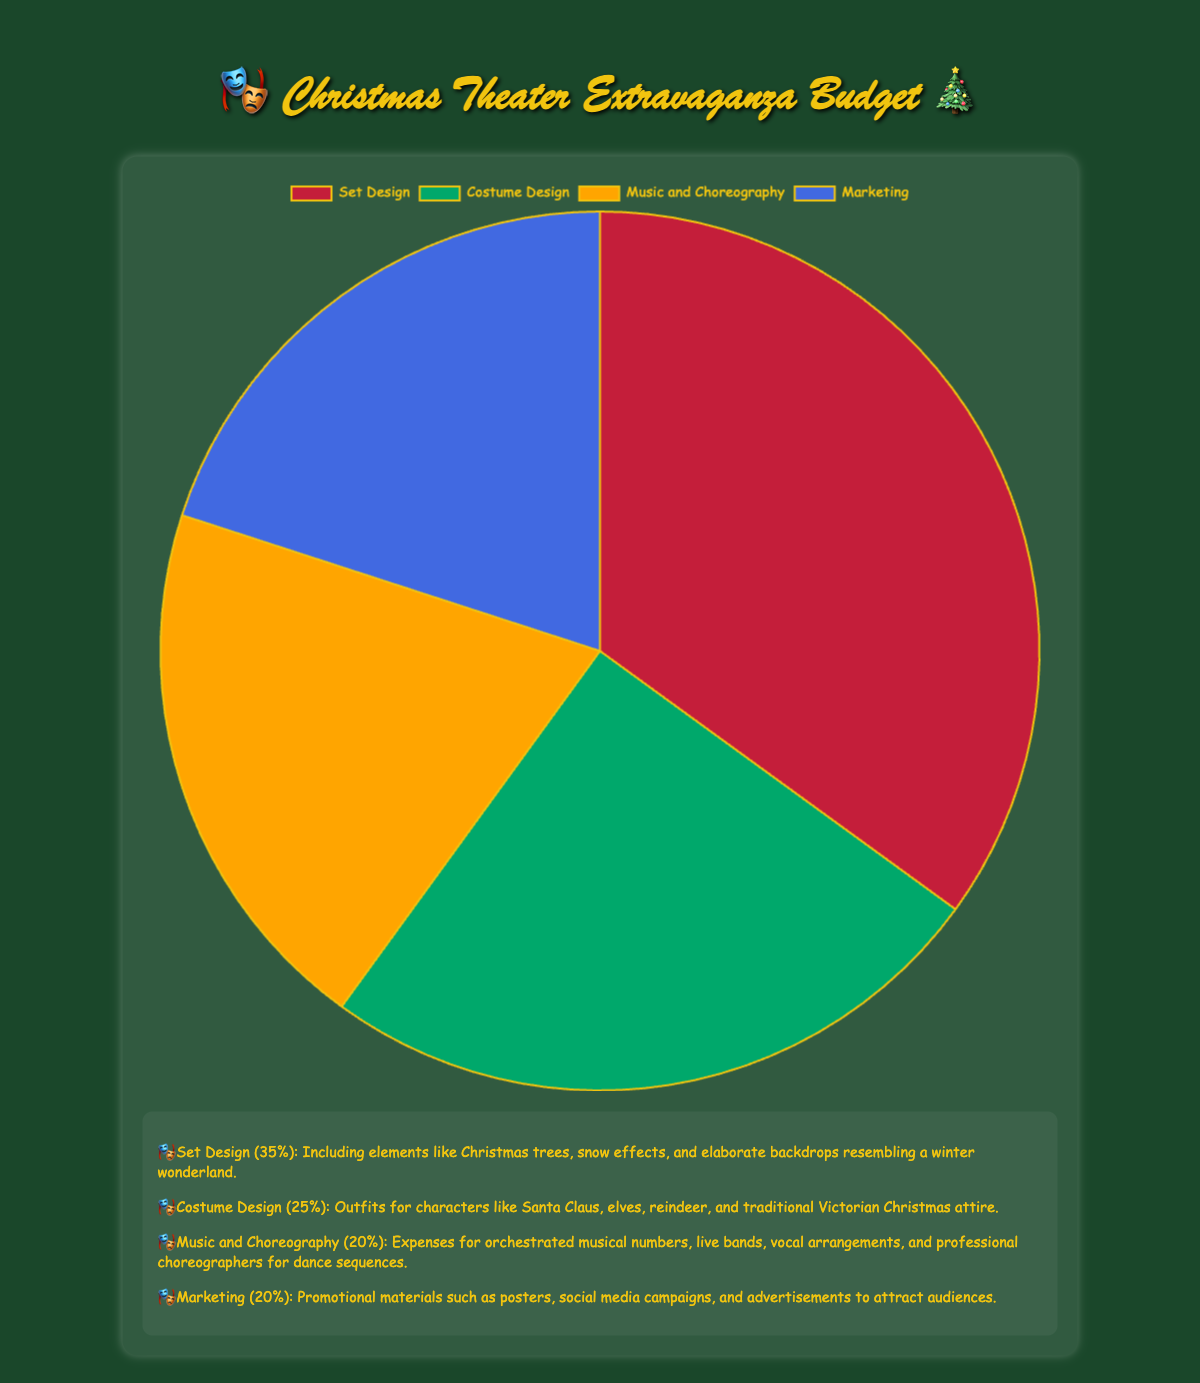What percentage of the budget is allocated to both Set Design and Costume Design combined? First, identify the percentages for Set Design and Costume Design separately, which are 35% and 25%. Then, add these two percentages together: 35% + 25% = 60%.
Answer: 60% Which category receives a larger portion of the budget, Music and Choreography or Marketing? Compare the percentages allocated to both categories. Music and Choreography has 20% and so does Marketing. Therefore, they receive equal portions of the budget.
Answer: Neither, they are equal What is the smallest allocation category, and what percentage of the budget does it receive? Review the percentages for each category. Both Music and Choreography and Marketing have the smallest percentages at 20%.
Answer: Music and Choreography and Marketing, 20% If the budget for Music and Choreography were increased by 10%, what would the new percentage be? Begin with the original percentage for Music and Choreography, which is 20%. Then add 10% to it: 20% + 10% = 30%.
Answer: 30% What is the difference in budget allocation between Set Design and Music and Choreography? Identify the percentages for Set Design and Music and Choreography, which are 35% and 20% respectively. Subtract the smaller percentage from the larger one: 35% - 20% = 15%.
Answer: 15% Which category is depicted using the color green in the chart? Observe the color scheme of the graph. The green section corresponds to Costume Design.
Answer: Costume Design What fraction of the budget is allocated to Marketing relative to the total budget? The percentage allocated to Marketing is 20%. To express this as a fraction of the total budget of 100%, divide 20 by 100: 20/100 = 1/5.
Answer: 1/5 If you were to split the total budget allocation equally among all categories, what would each category's percentage be? There are 4 categories in total. To find the equal share for each category, divide 100% by 4: 100% / 4 = 25%.
Answer: 25% Which category has exactly 10% more budget allocation than Music and Choreography? Identify Music and Choreography's percentage (20%) and add 10% to it to get 30%. No category has exactly 30%, so no category fits this condition.
Answer: None 